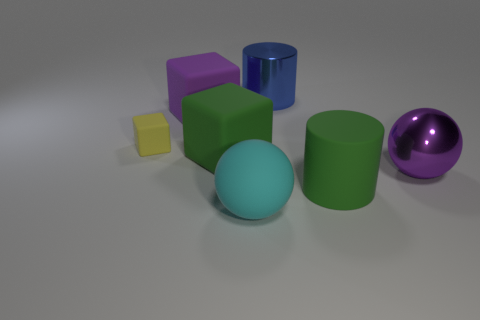There is a cube that is the same color as the rubber cylinder; what is its size?
Provide a succinct answer. Large. What number of other things are there of the same shape as the yellow thing?
Ensure brevity in your answer.  2. The shiny thing that is in front of the tiny yellow thing is what color?
Your answer should be very brief. Purple. Does the blue object have the same size as the purple metal sphere?
Your answer should be very brief. Yes. There is a cylinder behind the big metallic thing in front of the tiny yellow matte cube; what is its material?
Offer a very short reply. Metal. What number of shiny cylinders are the same color as the big shiny ball?
Provide a succinct answer. 0. Are there any other things that have the same material as the blue thing?
Your answer should be compact. Yes. Are there fewer green blocks that are in front of the big matte sphere than purple blocks?
Your answer should be very brief. Yes. What is the color of the large metallic thing on the left side of the large green matte object right of the big metal cylinder?
Provide a short and direct response. Blue. There is a green matte thing left of the metal thing to the left of the ball right of the cyan matte object; how big is it?
Provide a short and direct response. Large. 